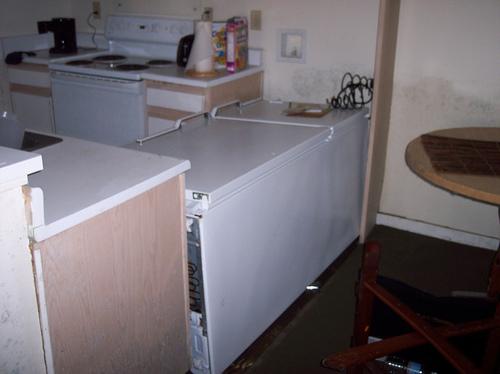Is there a way to make coffee?
Concise answer only. Yes. What kind of room is this?
Give a very brief answer. Kitchen. Is there a roll of paper towels?
Answer briefly. Yes. How many electrical appliances are showing?
Concise answer only. 3. 